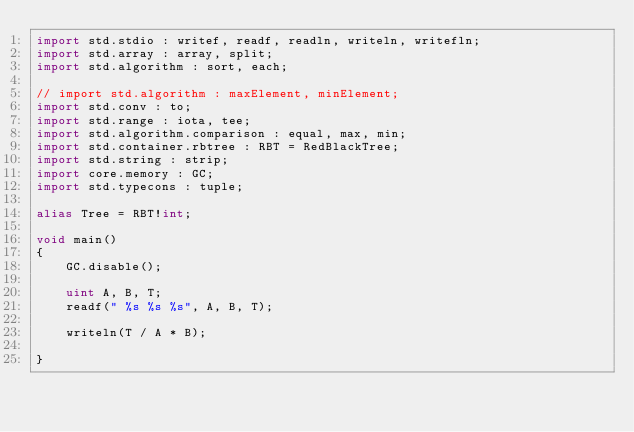Convert code to text. <code><loc_0><loc_0><loc_500><loc_500><_D_>import std.stdio : writef, readf, readln, writeln, writefln;
import std.array : array, split;
import std.algorithm : sort, each;

// import std.algorithm : maxElement, minElement;
import std.conv : to;
import std.range : iota, tee;
import std.algorithm.comparison : equal, max, min;
import std.container.rbtree : RBT = RedBlackTree;
import std.string : strip;
import core.memory : GC;
import std.typecons : tuple;

alias Tree = RBT!int;

void main()
{
    GC.disable();

    uint A, B, T;
    readf(" %s %s %s", A, B, T);

    writeln(T / A * B);

}
</code> 